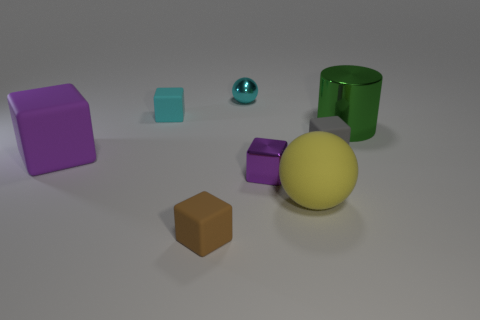Is there any other thing that has the same shape as the green metallic thing?
Your response must be concise. No. What is the shape of the tiny matte thing that is in front of the matte thing to the right of the large yellow sphere?
Keep it short and to the point. Cube. What is the color of the other big thing that is made of the same material as the big yellow thing?
Your answer should be very brief. Purple. Do the big matte cube and the metal block have the same color?
Ensure brevity in your answer.  Yes. There is a purple object that is the same size as the yellow ball; what is its shape?
Provide a short and direct response. Cube. What size is the gray cube?
Ensure brevity in your answer.  Small. Do the purple thing that is left of the purple shiny object and the rubber object that is on the right side of the big sphere have the same size?
Your answer should be compact. No. What is the color of the ball that is behind the large thing that is left of the cyan metallic object?
Ensure brevity in your answer.  Cyan. What is the material of the cylinder that is the same size as the yellow object?
Your answer should be compact. Metal. What number of rubber things are either small brown cubes or small cubes?
Offer a very short reply. 3. 